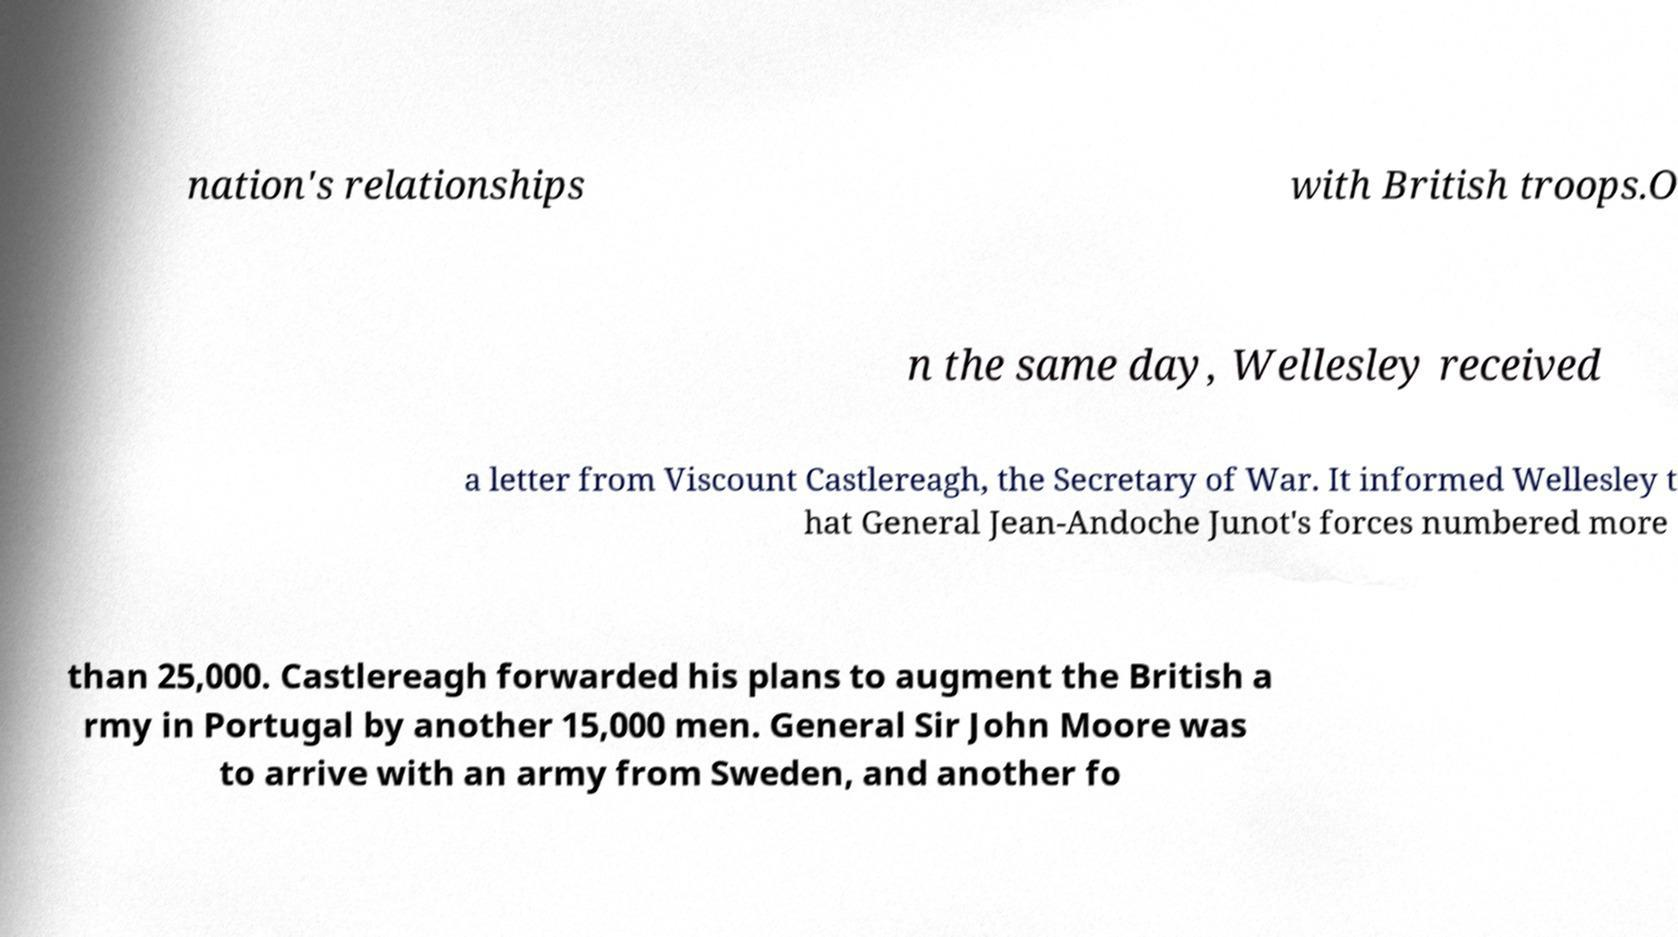There's text embedded in this image that I need extracted. Can you transcribe it verbatim? nation's relationships with British troops.O n the same day, Wellesley received a letter from Viscount Castlereagh, the Secretary of War. It informed Wellesley t hat General Jean-Andoche Junot's forces numbered more than 25,000. Castlereagh forwarded his plans to augment the British a rmy in Portugal by another 15,000 men. General Sir John Moore was to arrive with an army from Sweden, and another fo 